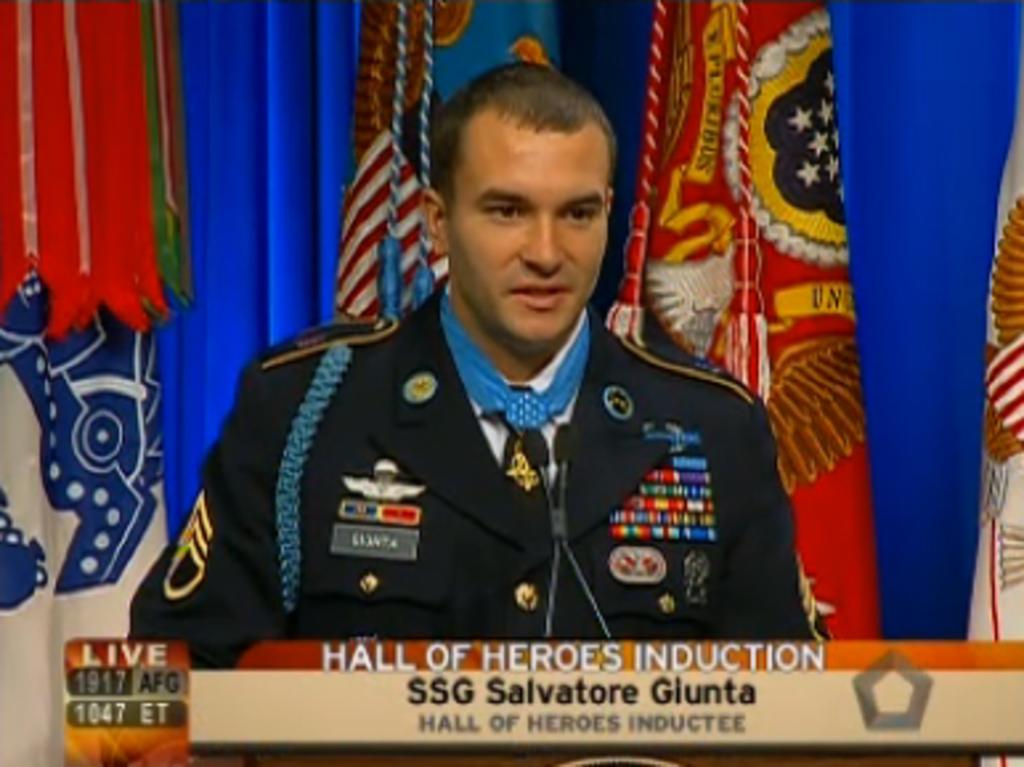Who or what is the main subject in the image? There is a person in the image. What is the person wearing in the image? The person is wearing a blazer. Is there any text or writing present in the image? Yes, there is text or writing at the bottom of the image. What type of window treatment can be seen in the image? There are curtains visible in the image. What type of cheese is being offered to the person in the wilderness in the image? There is no cheese or wilderness present in the image; it features a person wearing a blazer with text or writing at the bottom and curtains visible. 